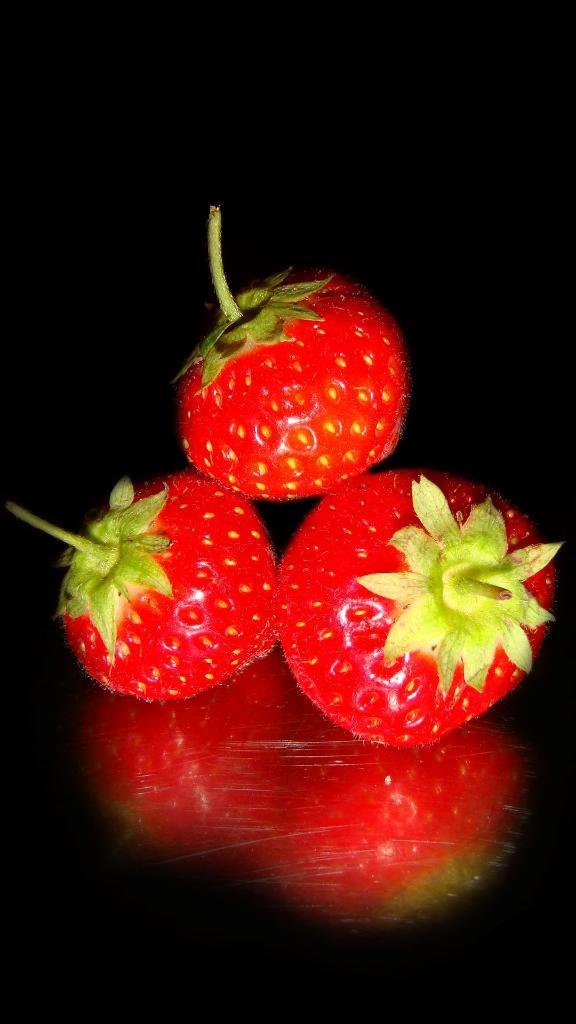How many strawberries are visible in the image? There are three strawberries in the image. What can be observed about the background of the image? The background of the image appears dark. How many women are present in the image? There are no women present in the image; it only features strawberries. Can you see any clovers in the image? There are no clovers visible in the image; it only features strawberries. 